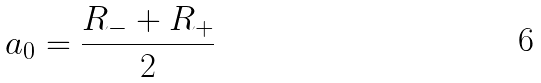<formula> <loc_0><loc_0><loc_500><loc_500>a _ { 0 } = \frac { R _ { - } + R _ { + } } { 2 }</formula> 